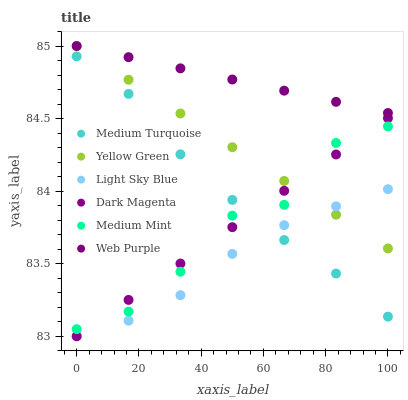Does Light Sky Blue have the minimum area under the curve?
Answer yes or no. Yes. Does Web Purple have the maximum area under the curve?
Answer yes or no. Yes. Does Yellow Green have the minimum area under the curve?
Answer yes or no. No. Does Yellow Green have the maximum area under the curve?
Answer yes or no. No. Is Yellow Green the smoothest?
Answer yes or no. Yes. Is Medium Mint the roughest?
Answer yes or no. Yes. Is Web Purple the smoothest?
Answer yes or no. No. Is Web Purple the roughest?
Answer yes or no. No. Does Light Sky Blue have the lowest value?
Answer yes or no. Yes. Does Yellow Green have the lowest value?
Answer yes or no. No. Does Web Purple have the highest value?
Answer yes or no. Yes. Does Light Sky Blue have the highest value?
Answer yes or no. No. Is Medium Turquoise less than Web Purple?
Answer yes or no. Yes. Is Web Purple greater than Light Sky Blue?
Answer yes or no. Yes. Does Yellow Green intersect Dark Magenta?
Answer yes or no. Yes. Is Yellow Green less than Dark Magenta?
Answer yes or no. No. Is Yellow Green greater than Dark Magenta?
Answer yes or no. No. Does Medium Turquoise intersect Web Purple?
Answer yes or no. No. 